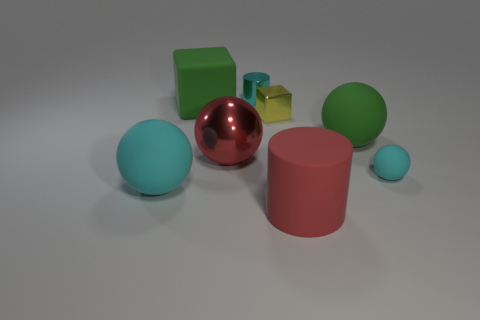Is the color of the big shiny ball the same as the large matte cylinder?
Your response must be concise. Yes. There is another object that is the same color as the large shiny object; what is it made of?
Offer a very short reply. Rubber. Is there any other thing that has the same shape as the small yellow metallic object?
Offer a very short reply. Yes. What material is the large thing in front of the large cyan object?
Give a very brief answer. Rubber. Is the material of the cylinder behind the yellow thing the same as the large red sphere?
Ensure brevity in your answer.  Yes. How many things are large rubber spheres or large green things that are behind the yellow metallic cube?
Provide a succinct answer. 3. The green thing that is the same shape as the red shiny object is what size?
Provide a short and direct response. Large. Are there any other things that are the same size as the red matte cylinder?
Give a very brief answer. Yes. There is a tiny rubber thing; are there any small balls behind it?
Make the answer very short. No. There is a big rubber ball on the left side of the tiny cylinder; is its color the same as the big shiny sphere that is in front of the green matte ball?
Offer a very short reply. No. 